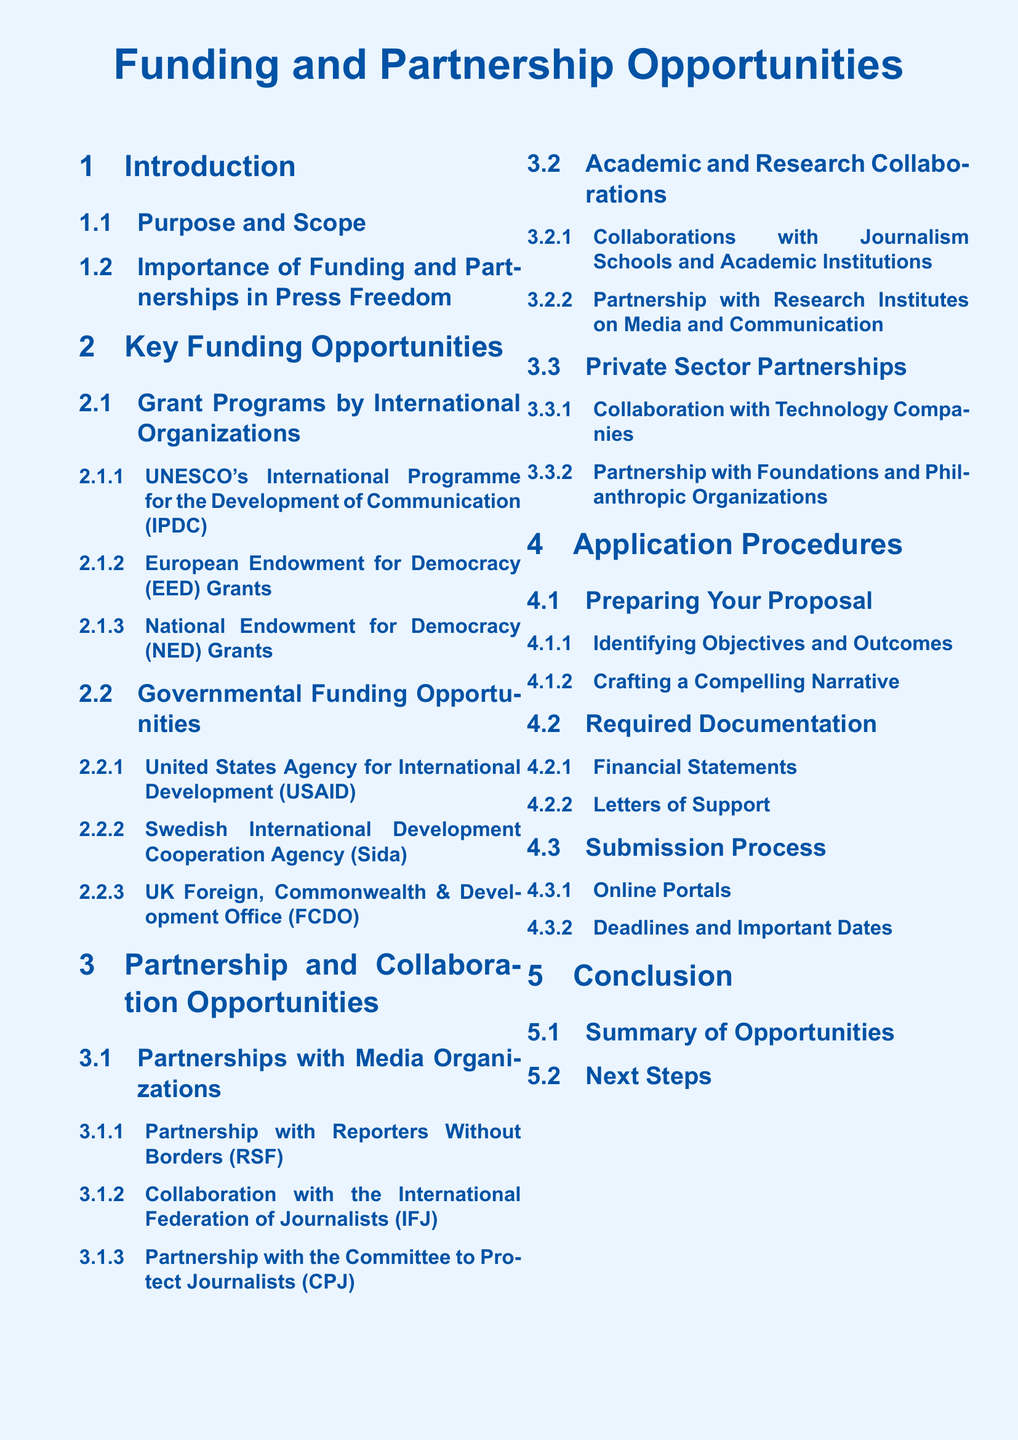What is the title of the document? The title of the document is prominently displayed at the center and provides the main subject of the content.
Answer: Funding and Partnership Opportunities What is one of the key funding opportunities listed? The document outlines various key funding opportunities, including notable grants from different organizations.
Answer: UNESCO's International Programme for the Development of Communication Name one governmental funding opportunity mentioned. The document includes a section that lists governmental funding opportunities for press freedom.
Answer: USAID What is the focus of partnerships mentioned in the document? The partnership section addresses opportunities for collaboration, specifying the types of organizations involved.
Answer: Media Organizations What is required for proposal preparation according to the document? The documentation specifies necessary steps clients must follow when preparing their proposals, including particular focus areas.
Answer: Identifying Objectives and Outcomes How many application procedure sub-sections are there? The application procedures section is divided into multiple sub-topics that detail the process comprehensively.
Answer: Three What kind of organizations are mentioned for private sector partnerships? The document identifies specific types of organizations that can serve as partners in the private sector.
Answer: Technology Companies What is emphasized in the conclusion section? The conclusion summarizes the content and provides guidance on subsequent actions.
Answer: Summary of Opportunities 